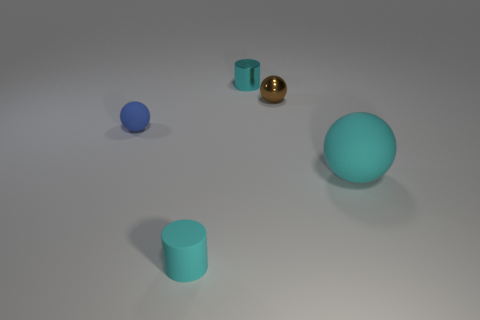Add 4 large red metallic balls. How many objects exist? 9 Subtract all spheres. How many objects are left? 2 Subtract 0 gray cylinders. How many objects are left? 5 Subtract all small things. Subtract all big red shiny cubes. How many objects are left? 1 Add 1 small brown spheres. How many small brown spheres are left? 2 Add 1 small metallic spheres. How many small metallic spheres exist? 2 